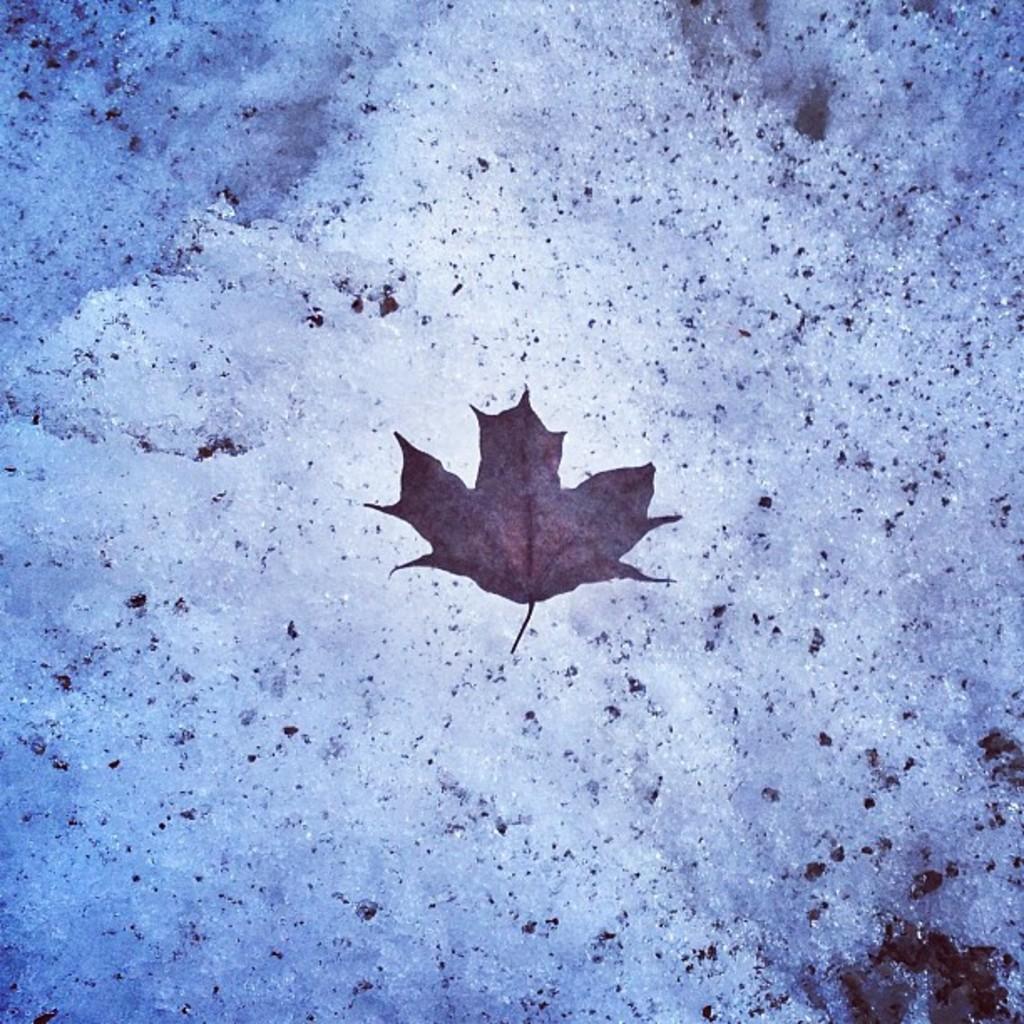Describe this image in one or two sentences. In the center of the image we can see a dry leaf. In the background of the image we can see the ice. 